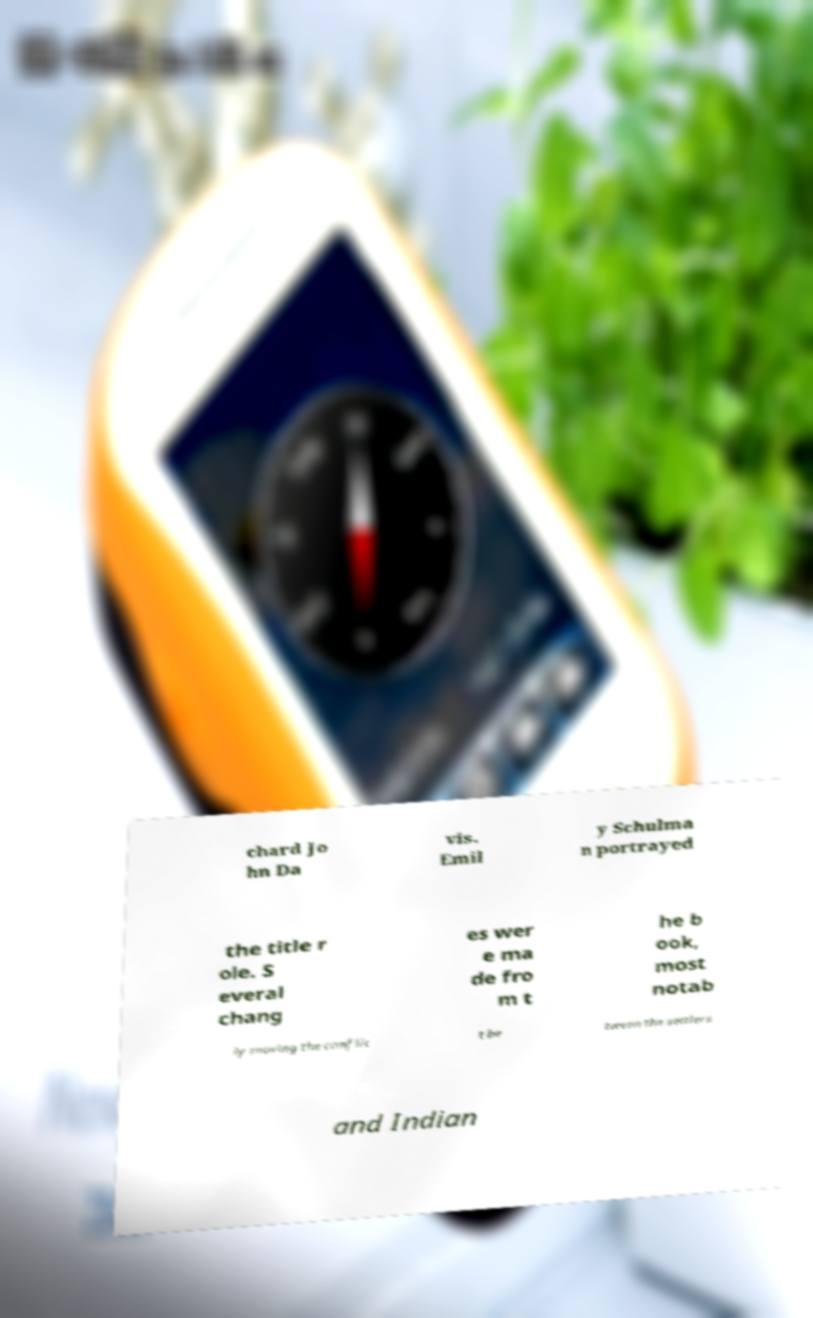I need the written content from this picture converted into text. Can you do that? chard Jo hn Da vis. Emil y Schulma n portrayed the title r ole. S everal chang es wer e ma de fro m t he b ook, most notab ly moving the conflic t be tween the settlers and Indian 